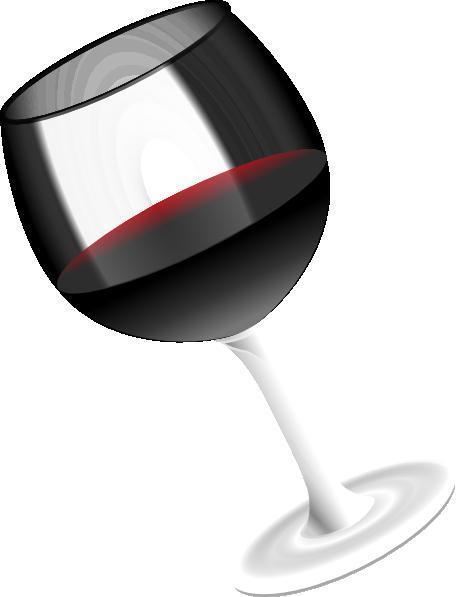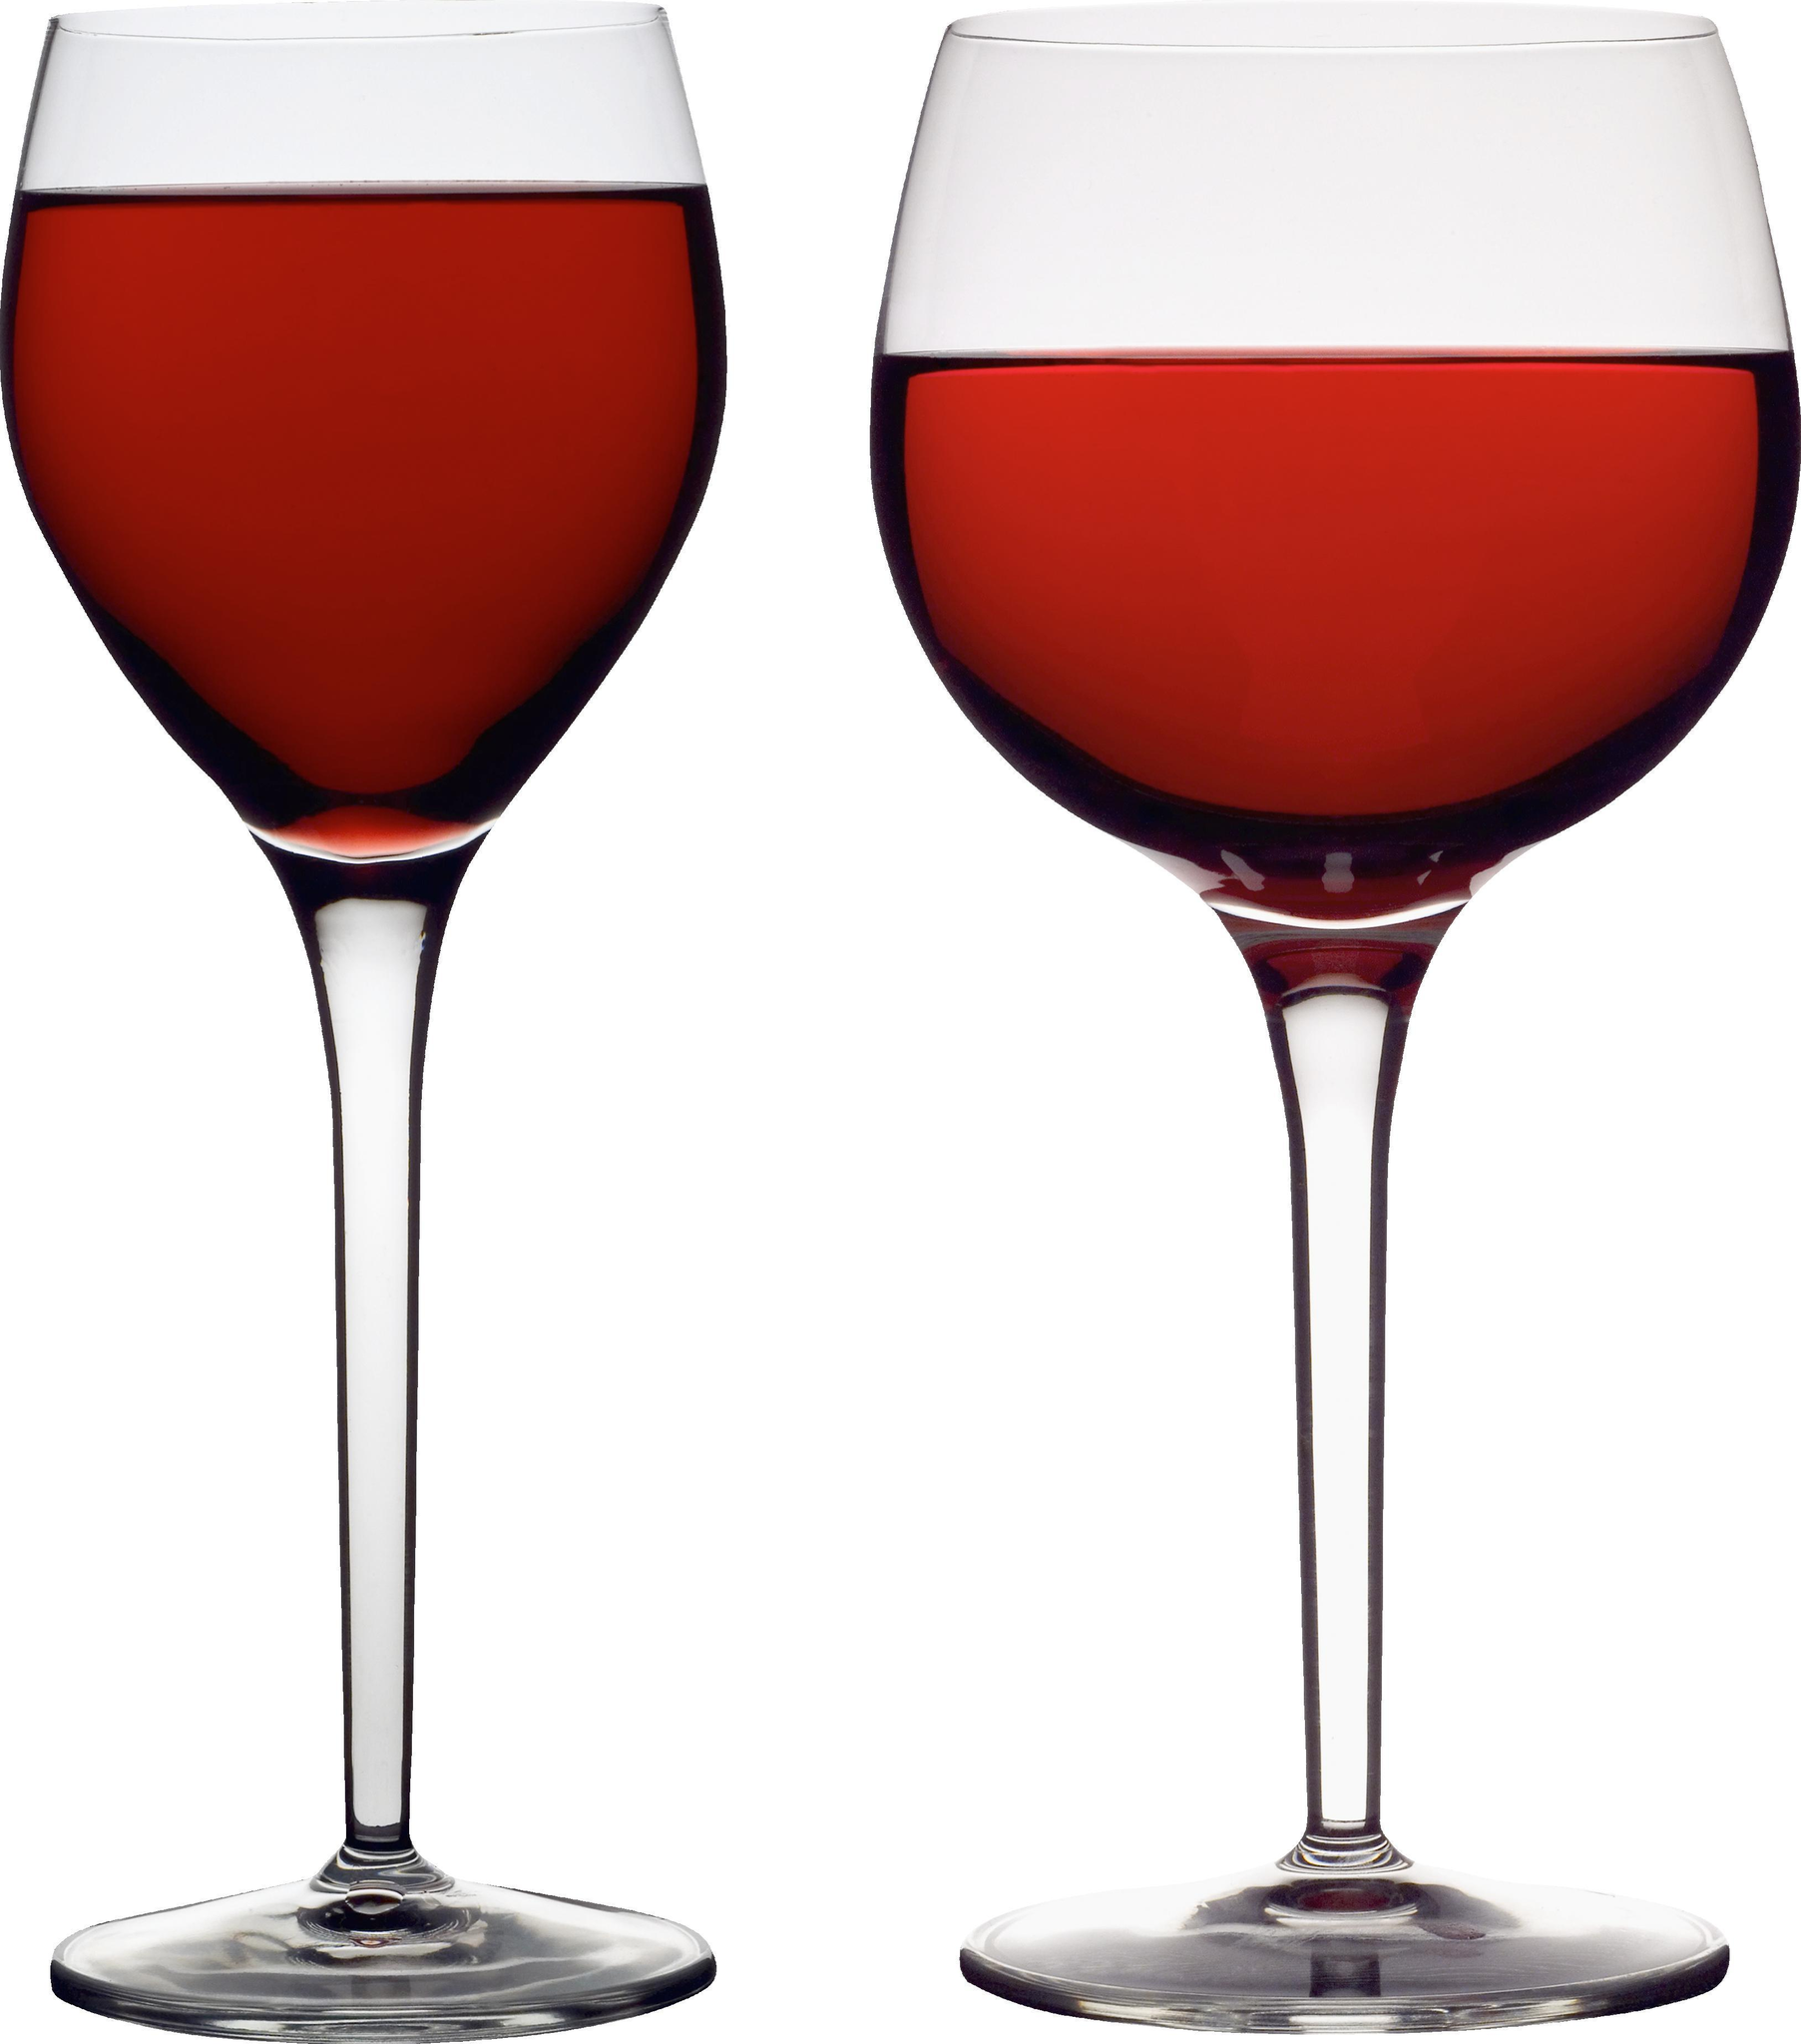The first image is the image on the left, the second image is the image on the right. Given the left and right images, does the statement "The left image shows two glasses of red wine while the right image shows one" hold true? Answer yes or no. No. The first image is the image on the left, the second image is the image on the right. For the images shown, is this caption "There is at least two wine glasses in the left image." true? Answer yes or no. No. 